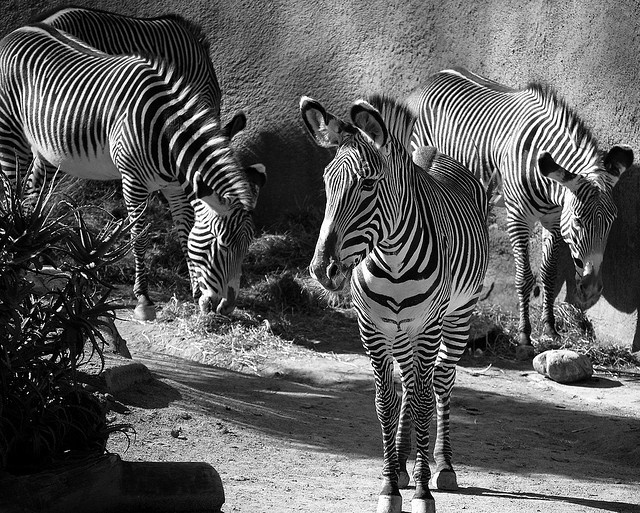Describe the objects in this image and their specific colors. I can see zebra in black, gray, darkgray, and lightgray tones, zebra in black, gray, lightgray, and darkgray tones, zebra in black, gray, white, and darkgray tones, and zebra in black, gray, darkgray, and lightgray tones in this image. 